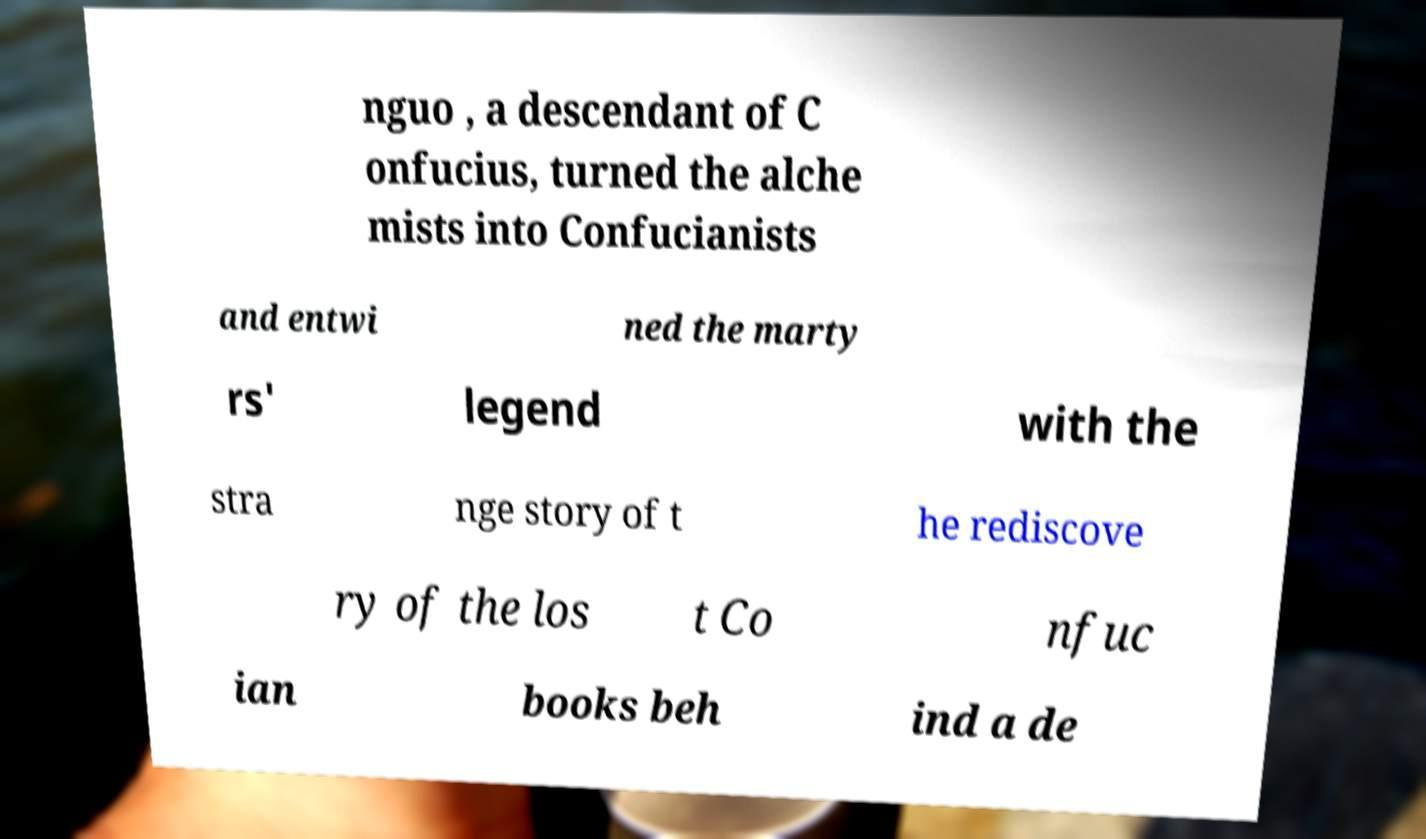Please read and relay the text visible in this image. What does it say? nguo , a descendant of C onfucius, turned the alche mists into Confucianists and entwi ned the marty rs' legend with the stra nge story of t he rediscove ry of the los t Co nfuc ian books beh ind a de 